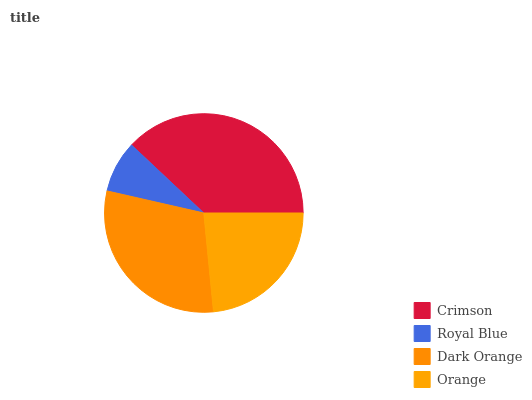Is Royal Blue the minimum?
Answer yes or no. Yes. Is Crimson the maximum?
Answer yes or no. Yes. Is Dark Orange the minimum?
Answer yes or no. No. Is Dark Orange the maximum?
Answer yes or no. No. Is Dark Orange greater than Royal Blue?
Answer yes or no. Yes. Is Royal Blue less than Dark Orange?
Answer yes or no. Yes. Is Royal Blue greater than Dark Orange?
Answer yes or no. No. Is Dark Orange less than Royal Blue?
Answer yes or no. No. Is Dark Orange the high median?
Answer yes or no. Yes. Is Orange the low median?
Answer yes or no. Yes. Is Crimson the high median?
Answer yes or no. No. Is Dark Orange the low median?
Answer yes or no. No. 